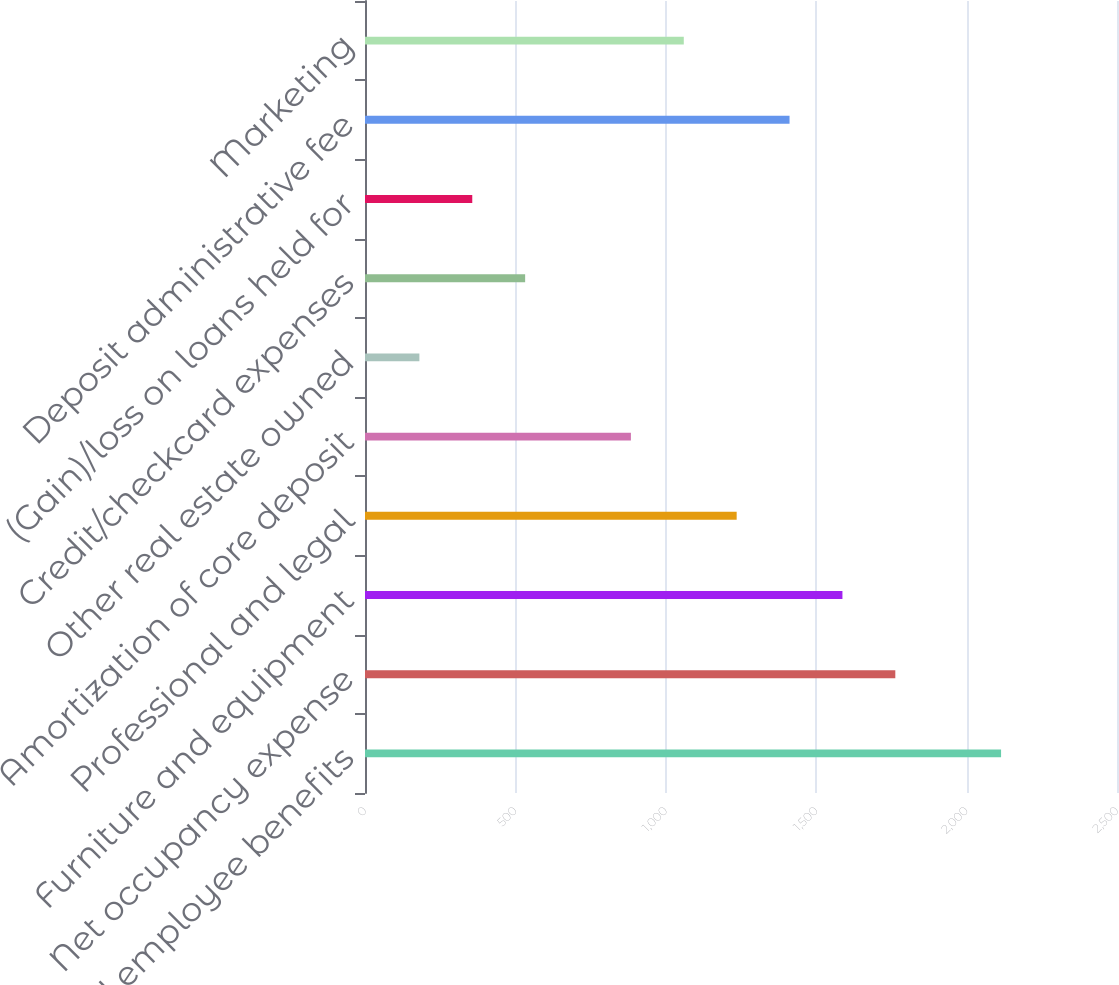Convert chart. <chart><loc_0><loc_0><loc_500><loc_500><bar_chart><fcel>Salaries and employee benefits<fcel>Net occupancy expense<fcel>Furniture and equipment<fcel>Professional and legal<fcel>Amortization of core deposit<fcel>Other real estate owned<fcel>Credit/checkcard expenses<fcel>(Gain)/loss on loans held for<fcel>Deposit administrative fee<fcel>Marketing<nl><fcel>2114.6<fcel>1763<fcel>1587.2<fcel>1235.6<fcel>884<fcel>180.8<fcel>532.4<fcel>356.6<fcel>1411.4<fcel>1059.8<nl></chart> 